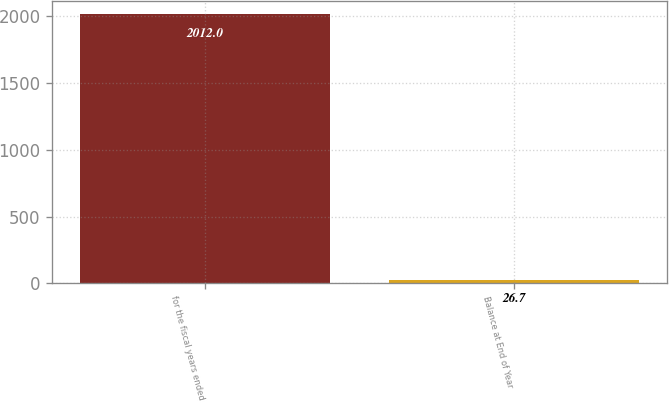Convert chart. <chart><loc_0><loc_0><loc_500><loc_500><bar_chart><fcel>for the fiscal years ended<fcel>Balance at End of Year<nl><fcel>2012<fcel>26.7<nl></chart> 